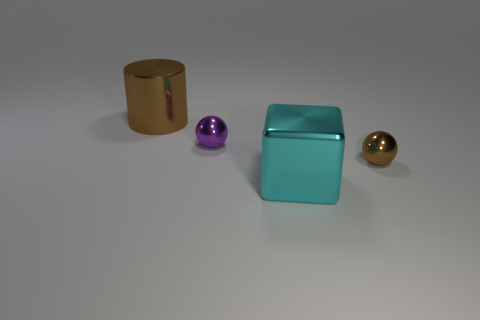Is the size of the brown metal cylinder the same as the brown thing that is in front of the cylinder?
Your answer should be very brief. No. What number of other objects are there of the same color as the metallic cube?
Give a very brief answer. 0. Are there more purple objects behind the tiny purple metal thing than spheres?
Offer a very short reply. No. The small shiny object in front of the tiny metal sphere to the left of the tiny metallic thing right of the big cube is what color?
Your response must be concise. Brown. Is the material of the small purple sphere the same as the big brown object?
Ensure brevity in your answer.  Yes. Is there a metal thing that has the same size as the brown cylinder?
Offer a terse response. Yes. What material is the brown object that is the same size as the cyan metallic cube?
Offer a very short reply. Metal. Is there a big brown thing of the same shape as the tiny brown shiny object?
Offer a very short reply. No. There is a small thing that is the same color as the metallic cylinder; what is its material?
Offer a very short reply. Metal. What is the shape of the big metal object that is left of the tiny purple metallic object?
Your answer should be very brief. Cylinder. 